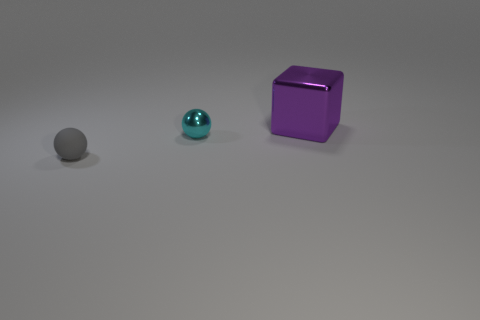Add 2 small blue balls. How many objects exist? 5 Subtract all balls. How many objects are left? 1 Add 1 small gray rubber things. How many small gray rubber things are left? 2 Add 1 large purple shiny objects. How many large purple shiny objects exist? 2 Subtract 0 gray cubes. How many objects are left? 3 Subtract all cyan shiny things. Subtract all small gray rubber balls. How many objects are left? 1 